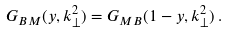Convert formula to latex. <formula><loc_0><loc_0><loc_500><loc_500>G _ { B M } ( y , k _ { \perp } ^ { 2 } ) = G _ { M B } ( 1 - y , k _ { \perp } ^ { 2 } ) \, .</formula> 